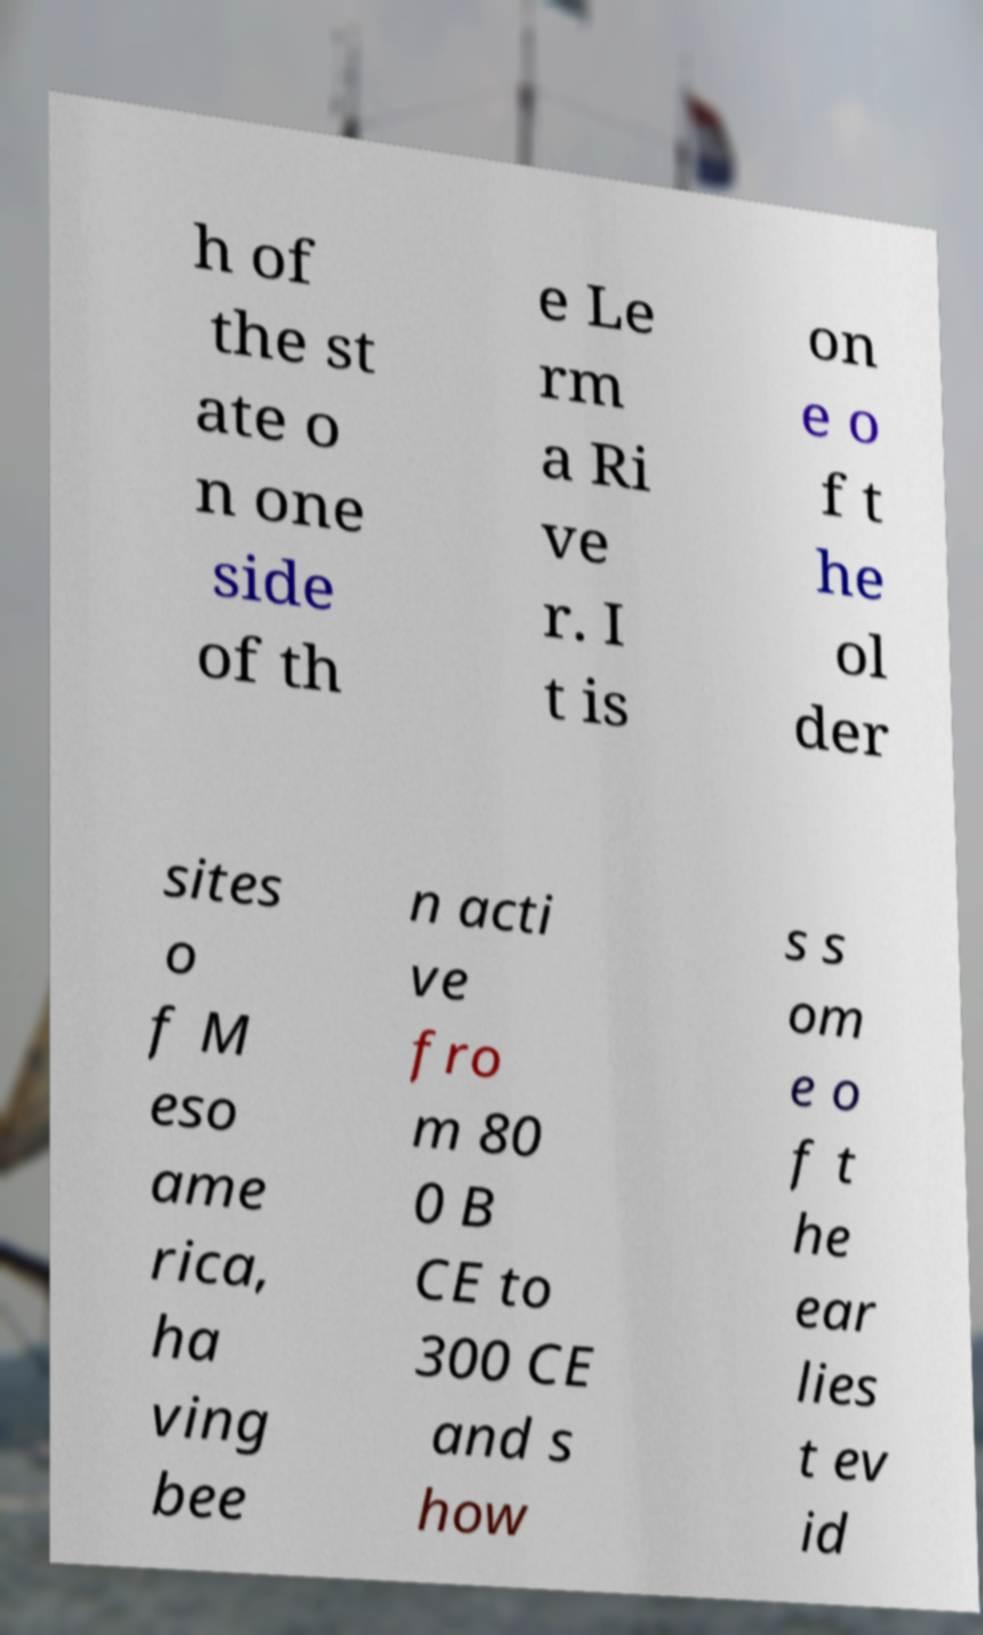There's text embedded in this image that I need extracted. Can you transcribe it verbatim? h of the st ate o n one side of th e Le rm a Ri ve r. I t is on e o f t he ol der sites o f M eso ame rica, ha ving bee n acti ve fro m 80 0 B CE to 300 CE and s how s s om e o f t he ear lies t ev id 